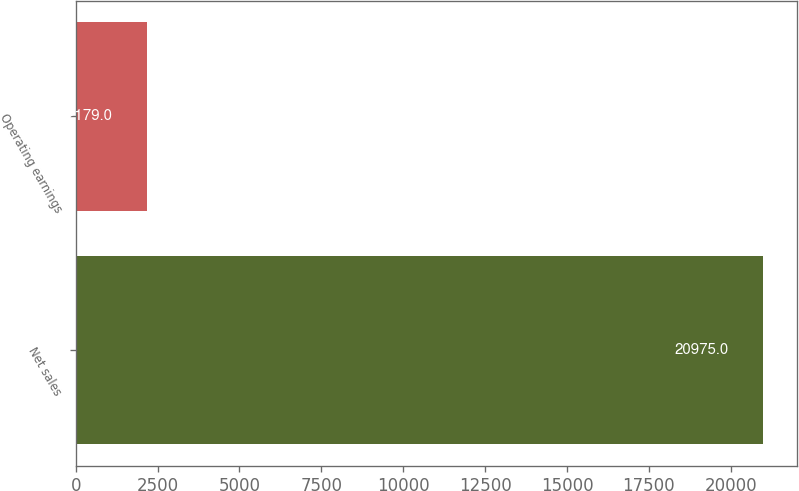Convert chart. <chart><loc_0><loc_0><loc_500><loc_500><bar_chart><fcel>Net sales<fcel>Operating earnings<nl><fcel>20975<fcel>2179<nl></chart> 